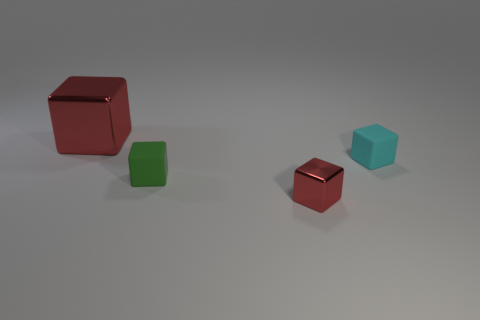Subtract all large cubes. How many cubes are left? 3 Add 3 red shiny objects. How many objects exist? 7 Subtract all cyan blocks. How many blocks are left? 3 Subtract all purple balls. How many red blocks are left? 2 Subtract 3 cubes. How many cubes are left? 1 Add 2 cyan objects. How many cyan objects are left? 3 Add 3 large gray shiny cylinders. How many large gray shiny cylinders exist? 3 Subtract 0 blue cylinders. How many objects are left? 4 Subtract all red blocks. Subtract all cyan cylinders. How many blocks are left? 2 Subtract all tiny green rubber cubes. Subtract all rubber cubes. How many objects are left? 1 